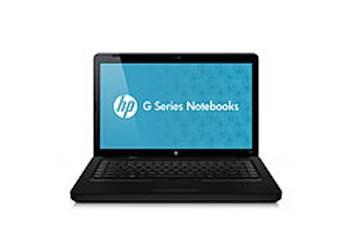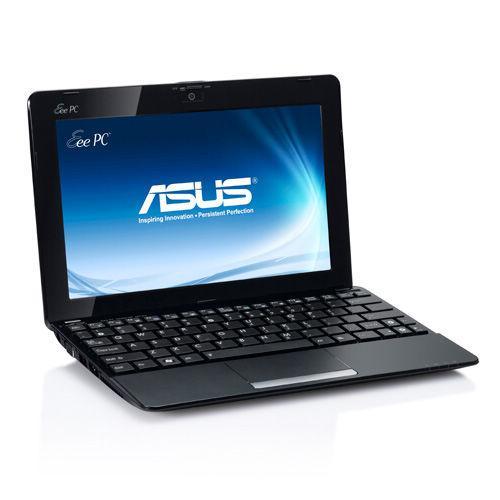The first image is the image on the left, the second image is the image on the right. Examine the images to the left and right. Is the description "the laptop in the image on the right is facing the bottom right" accurate? Answer yes or no. Yes. 